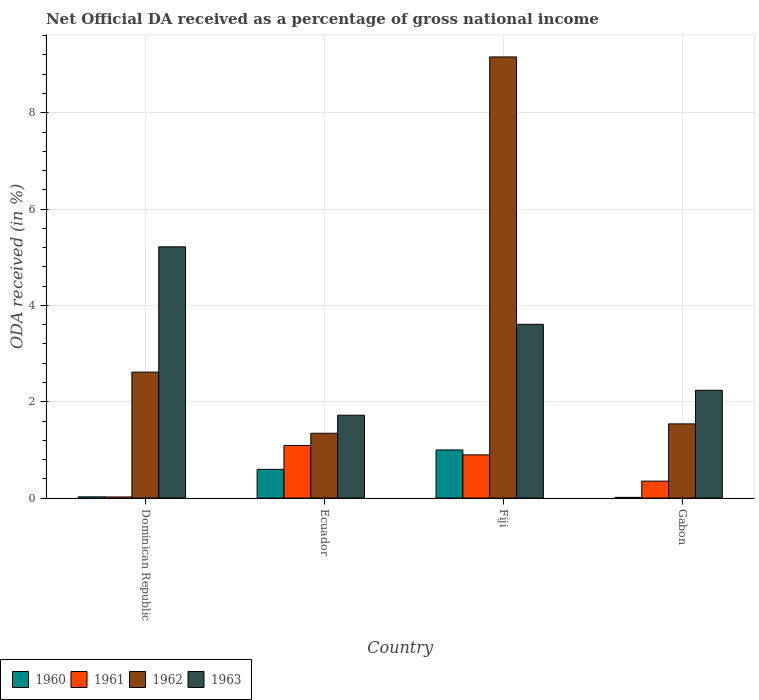How many groups of bars are there?
Provide a short and direct response. 4. Are the number of bars per tick equal to the number of legend labels?
Keep it short and to the point. Yes. How many bars are there on the 3rd tick from the right?
Provide a succinct answer. 4. What is the label of the 1st group of bars from the left?
Ensure brevity in your answer.  Dominican Republic. What is the net official DA received in 1962 in Dominican Republic?
Your response must be concise. 2.62. Across all countries, what is the maximum net official DA received in 1963?
Make the answer very short. 5.22. Across all countries, what is the minimum net official DA received in 1961?
Give a very brief answer. 0.02. In which country was the net official DA received in 1961 maximum?
Ensure brevity in your answer.  Ecuador. In which country was the net official DA received in 1960 minimum?
Offer a very short reply. Gabon. What is the total net official DA received in 1962 in the graph?
Provide a succinct answer. 14.66. What is the difference between the net official DA received in 1962 in Dominican Republic and that in Ecuador?
Ensure brevity in your answer.  1.27. What is the difference between the net official DA received in 1960 in Gabon and the net official DA received in 1961 in Ecuador?
Offer a terse response. -1.08. What is the average net official DA received in 1961 per country?
Offer a very short reply. 0.59. What is the difference between the net official DA received of/in 1961 and net official DA received of/in 1962 in Fiji?
Ensure brevity in your answer.  -8.26. In how many countries, is the net official DA received in 1963 greater than 1.6 %?
Your answer should be compact. 4. What is the ratio of the net official DA received in 1962 in Fiji to that in Gabon?
Provide a short and direct response. 5.94. Is the net official DA received in 1962 in Fiji less than that in Gabon?
Offer a terse response. No. What is the difference between the highest and the second highest net official DA received in 1963?
Provide a succinct answer. -1.37. What is the difference between the highest and the lowest net official DA received in 1960?
Provide a short and direct response. 0.98. In how many countries, is the net official DA received in 1962 greater than the average net official DA received in 1962 taken over all countries?
Provide a succinct answer. 1. What does the 4th bar from the left in Dominican Republic represents?
Make the answer very short. 1963. Is it the case that in every country, the sum of the net official DA received in 1962 and net official DA received in 1960 is greater than the net official DA received in 1963?
Offer a terse response. No. How many bars are there?
Give a very brief answer. 16. Are all the bars in the graph horizontal?
Provide a short and direct response. No. How many countries are there in the graph?
Your response must be concise. 4. Does the graph contain any zero values?
Your answer should be very brief. No. Does the graph contain grids?
Give a very brief answer. Yes. Where does the legend appear in the graph?
Provide a short and direct response. Bottom left. How are the legend labels stacked?
Keep it short and to the point. Horizontal. What is the title of the graph?
Keep it short and to the point. Net Official DA received as a percentage of gross national income. What is the label or title of the X-axis?
Your response must be concise. Country. What is the label or title of the Y-axis?
Offer a very short reply. ODA received (in %). What is the ODA received (in %) in 1960 in Dominican Republic?
Offer a terse response. 0.03. What is the ODA received (in %) of 1961 in Dominican Republic?
Make the answer very short. 0.02. What is the ODA received (in %) in 1962 in Dominican Republic?
Offer a very short reply. 2.62. What is the ODA received (in %) of 1963 in Dominican Republic?
Give a very brief answer. 5.22. What is the ODA received (in %) in 1960 in Ecuador?
Your answer should be compact. 0.6. What is the ODA received (in %) in 1961 in Ecuador?
Give a very brief answer. 1.09. What is the ODA received (in %) of 1962 in Ecuador?
Ensure brevity in your answer.  1.35. What is the ODA received (in %) of 1963 in Ecuador?
Offer a very short reply. 1.72. What is the ODA received (in %) in 1960 in Fiji?
Provide a succinct answer. 1. What is the ODA received (in %) of 1961 in Fiji?
Keep it short and to the point. 0.9. What is the ODA received (in %) of 1962 in Fiji?
Offer a very short reply. 9.16. What is the ODA received (in %) of 1963 in Fiji?
Ensure brevity in your answer.  3.61. What is the ODA received (in %) in 1960 in Gabon?
Offer a very short reply. 0.01. What is the ODA received (in %) in 1961 in Gabon?
Provide a succinct answer. 0.35. What is the ODA received (in %) in 1962 in Gabon?
Make the answer very short. 1.54. What is the ODA received (in %) in 1963 in Gabon?
Keep it short and to the point. 2.24. Across all countries, what is the maximum ODA received (in %) of 1960?
Give a very brief answer. 1. Across all countries, what is the maximum ODA received (in %) in 1961?
Ensure brevity in your answer.  1.09. Across all countries, what is the maximum ODA received (in %) in 1962?
Your answer should be compact. 9.16. Across all countries, what is the maximum ODA received (in %) of 1963?
Your answer should be compact. 5.22. Across all countries, what is the minimum ODA received (in %) of 1960?
Your response must be concise. 0.01. Across all countries, what is the minimum ODA received (in %) of 1961?
Give a very brief answer. 0.02. Across all countries, what is the minimum ODA received (in %) of 1962?
Offer a terse response. 1.35. Across all countries, what is the minimum ODA received (in %) of 1963?
Your response must be concise. 1.72. What is the total ODA received (in %) in 1960 in the graph?
Give a very brief answer. 1.64. What is the total ODA received (in %) in 1961 in the graph?
Provide a succinct answer. 2.37. What is the total ODA received (in %) of 1962 in the graph?
Offer a very short reply. 14.66. What is the total ODA received (in %) of 1963 in the graph?
Offer a very short reply. 12.78. What is the difference between the ODA received (in %) in 1960 in Dominican Republic and that in Ecuador?
Provide a succinct answer. -0.57. What is the difference between the ODA received (in %) in 1961 in Dominican Republic and that in Ecuador?
Offer a terse response. -1.07. What is the difference between the ODA received (in %) in 1962 in Dominican Republic and that in Ecuador?
Provide a short and direct response. 1.27. What is the difference between the ODA received (in %) in 1963 in Dominican Republic and that in Ecuador?
Your answer should be very brief. 3.5. What is the difference between the ODA received (in %) in 1960 in Dominican Republic and that in Fiji?
Provide a succinct answer. -0.97. What is the difference between the ODA received (in %) of 1961 in Dominican Republic and that in Fiji?
Your response must be concise. -0.87. What is the difference between the ODA received (in %) of 1962 in Dominican Republic and that in Fiji?
Offer a terse response. -6.54. What is the difference between the ODA received (in %) of 1963 in Dominican Republic and that in Fiji?
Make the answer very short. 1.61. What is the difference between the ODA received (in %) of 1960 in Dominican Republic and that in Gabon?
Offer a very short reply. 0.01. What is the difference between the ODA received (in %) in 1961 in Dominican Republic and that in Gabon?
Offer a terse response. -0.33. What is the difference between the ODA received (in %) in 1962 in Dominican Republic and that in Gabon?
Offer a very short reply. 1.07. What is the difference between the ODA received (in %) of 1963 in Dominican Republic and that in Gabon?
Your answer should be compact. 2.98. What is the difference between the ODA received (in %) in 1960 in Ecuador and that in Fiji?
Make the answer very short. -0.4. What is the difference between the ODA received (in %) in 1961 in Ecuador and that in Fiji?
Your answer should be compact. 0.2. What is the difference between the ODA received (in %) in 1962 in Ecuador and that in Fiji?
Keep it short and to the point. -7.81. What is the difference between the ODA received (in %) of 1963 in Ecuador and that in Fiji?
Give a very brief answer. -1.89. What is the difference between the ODA received (in %) in 1960 in Ecuador and that in Gabon?
Provide a succinct answer. 0.58. What is the difference between the ODA received (in %) in 1961 in Ecuador and that in Gabon?
Ensure brevity in your answer.  0.74. What is the difference between the ODA received (in %) in 1962 in Ecuador and that in Gabon?
Your response must be concise. -0.2. What is the difference between the ODA received (in %) of 1963 in Ecuador and that in Gabon?
Ensure brevity in your answer.  -0.52. What is the difference between the ODA received (in %) of 1960 in Fiji and that in Gabon?
Make the answer very short. 0.98. What is the difference between the ODA received (in %) in 1961 in Fiji and that in Gabon?
Provide a short and direct response. 0.55. What is the difference between the ODA received (in %) of 1962 in Fiji and that in Gabon?
Give a very brief answer. 7.62. What is the difference between the ODA received (in %) in 1963 in Fiji and that in Gabon?
Make the answer very short. 1.37. What is the difference between the ODA received (in %) of 1960 in Dominican Republic and the ODA received (in %) of 1961 in Ecuador?
Provide a short and direct response. -1.07. What is the difference between the ODA received (in %) of 1960 in Dominican Republic and the ODA received (in %) of 1962 in Ecuador?
Provide a short and direct response. -1.32. What is the difference between the ODA received (in %) in 1960 in Dominican Republic and the ODA received (in %) in 1963 in Ecuador?
Offer a very short reply. -1.69. What is the difference between the ODA received (in %) of 1961 in Dominican Republic and the ODA received (in %) of 1962 in Ecuador?
Your response must be concise. -1.32. What is the difference between the ODA received (in %) in 1961 in Dominican Republic and the ODA received (in %) in 1963 in Ecuador?
Give a very brief answer. -1.7. What is the difference between the ODA received (in %) of 1962 in Dominican Republic and the ODA received (in %) of 1963 in Ecuador?
Keep it short and to the point. 0.9. What is the difference between the ODA received (in %) of 1960 in Dominican Republic and the ODA received (in %) of 1961 in Fiji?
Make the answer very short. -0.87. What is the difference between the ODA received (in %) in 1960 in Dominican Republic and the ODA received (in %) in 1962 in Fiji?
Provide a succinct answer. -9.13. What is the difference between the ODA received (in %) in 1960 in Dominican Republic and the ODA received (in %) in 1963 in Fiji?
Provide a short and direct response. -3.58. What is the difference between the ODA received (in %) in 1961 in Dominican Republic and the ODA received (in %) in 1962 in Fiji?
Provide a succinct answer. -9.14. What is the difference between the ODA received (in %) in 1961 in Dominican Republic and the ODA received (in %) in 1963 in Fiji?
Your response must be concise. -3.58. What is the difference between the ODA received (in %) in 1962 in Dominican Republic and the ODA received (in %) in 1963 in Fiji?
Your answer should be very brief. -0.99. What is the difference between the ODA received (in %) in 1960 in Dominican Republic and the ODA received (in %) in 1961 in Gabon?
Offer a very short reply. -0.33. What is the difference between the ODA received (in %) of 1960 in Dominican Republic and the ODA received (in %) of 1962 in Gabon?
Give a very brief answer. -1.52. What is the difference between the ODA received (in %) in 1960 in Dominican Republic and the ODA received (in %) in 1963 in Gabon?
Provide a succinct answer. -2.21. What is the difference between the ODA received (in %) in 1961 in Dominican Republic and the ODA received (in %) in 1962 in Gabon?
Give a very brief answer. -1.52. What is the difference between the ODA received (in %) of 1961 in Dominican Republic and the ODA received (in %) of 1963 in Gabon?
Your answer should be very brief. -2.21. What is the difference between the ODA received (in %) in 1962 in Dominican Republic and the ODA received (in %) in 1963 in Gabon?
Your answer should be very brief. 0.38. What is the difference between the ODA received (in %) of 1960 in Ecuador and the ODA received (in %) of 1961 in Fiji?
Make the answer very short. -0.3. What is the difference between the ODA received (in %) in 1960 in Ecuador and the ODA received (in %) in 1962 in Fiji?
Provide a short and direct response. -8.56. What is the difference between the ODA received (in %) in 1960 in Ecuador and the ODA received (in %) in 1963 in Fiji?
Ensure brevity in your answer.  -3.01. What is the difference between the ODA received (in %) in 1961 in Ecuador and the ODA received (in %) in 1962 in Fiji?
Offer a terse response. -8.07. What is the difference between the ODA received (in %) of 1961 in Ecuador and the ODA received (in %) of 1963 in Fiji?
Offer a very short reply. -2.52. What is the difference between the ODA received (in %) in 1962 in Ecuador and the ODA received (in %) in 1963 in Fiji?
Give a very brief answer. -2.26. What is the difference between the ODA received (in %) in 1960 in Ecuador and the ODA received (in %) in 1961 in Gabon?
Your answer should be very brief. 0.24. What is the difference between the ODA received (in %) of 1960 in Ecuador and the ODA received (in %) of 1962 in Gabon?
Your answer should be very brief. -0.94. What is the difference between the ODA received (in %) of 1960 in Ecuador and the ODA received (in %) of 1963 in Gabon?
Provide a succinct answer. -1.64. What is the difference between the ODA received (in %) of 1961 in Ecuador and the ODA received (in %) of 1962 in Gabon?
Keep it short and to the point. -0.45. What is the difference between the ODA received (in %) of 1961 in Ecuador and the ODA received (in %) of 1963 in Gabon?
Provide a succinct answer. -1.15. What is the difference between the ODA received (in %) in 1962 in Ecuador and the ODA received (in %) in 1963 in Gabon?
Provide a short and direct response. -0.89. What is the difference between the ODA received (in %) in 1960 in Fiji and the ODA received (in %) in 1961 in Gabon?
Give a very brief answer. 0.65. What is the difference between the ODA received (in %) in 1960 in Fiji and the ODA received (in %) in 1962 in Gabon?
Provide a succinct answer. -0.54. What is the difference between the ODA received (in %) of 1960 in Fiji and the ODA received (in %) of 1963 in Gabon?
Ensure brevity in your answer.  -1.24. What is the difference between the ODA received (in %) of 1961 in Fiji and the ODA received (in %) of 1962 in Gabon?
Your answer should be compact. -0.64. What is the difference between the ODA received (in %) of 1961 in Fiji and the ODA received (in %) of 1963 in Gabon?
Provide a short and direct response. -1.34. What is the difference between the ODA received (in %) in 1962 in Fiji and the ODA received (in %) in 1963 in Gabon?
Provide a succinct answer. 6.92. What is the average ODA received (in %) of 1960 per country?
Give a very brief answer. 0.41. What is the average ODA received (in %) of 1961 per country?
Your answer should be compact. 0.59. What is the average ODA received (in %) of 1962 per country?
Ensure brevity in your answer.  3.67. What is the average ODA received (in %) in 1963 per country?
Provide a succinct answer. 3.2. What is the difference between the ODA received (in %) of 1960 and ODA received (in %) of 1961 in Dominican Republic?
Provide a succinct answer. 0. What is the difference between the ODA received (in %) in 1960 and ODA received (in %) in 1962 in Dominican Republic?
Provide a short and direct response. -2.59. What is the difference between the ODA received (in %) of 1960 and ODA received (in %) of 1963 in Dominican Republic?
Provide a succinct answer. -5.19. What is the difference between the ODA received (in %) of 1961 and ODA received (in %) of 1962 in Dominican Republic?
Your response must be concise. -2.59. What is the difference between the ODA received (in %) of 1961 and ODA received (in %) of 1963 in Dominican Republic?
Your answer should be very brief. -5.19. What is the difference between the ODA received (in %) of 1962 and ODA received (in %) of 1963 in Dominican Republic?
Your answer should be compact. -2.6. What is the difference between the ODA received (in %) of 1960 and ODA received (in %) of 1961 in Ecuador?
Your answer should be compact. -0.5. What is the difference between the ODA received (in %) in 1960 and ODA received (in %) in 1962 in Ecuador?
Your response must be concise. -0.75. What is the difference between the ODA received (in %) in 1960 and ODA received (in %) in 1963 in Ecuador?
Provide a short and direct response. -1.12. What is the difference between the ODA received (in %) of 1961 and ODA received (in %) of 1962 in Ecuador?
Make the answer very short. -0.25. What is the difference between the ODA received (in %) of 1961 and ODA received (in %) of 1963 in Ecuador?
Offer a terse response. -0.63. What is the difference between the ODA received (in %) in 1962 and ODA received (in %) in 1963 in Ecuador?
Your answer should be very brief. -0.37. What is the difference between the ODA received (in %) of 1960 and ODA received (in %) of 1961 in Fiji?
Provide a short and direct response. 0.1. What is the difference between the ODA received (in %) of 1960 and ODA received (in %) of 1962 in Fiji?
Keep it short and to the point. -8.16. What is the difference between the ODA received (in %) in 1960 and ODA received (in %) in 1963 in Fiji?
Your answer should be very brief. -2.61. What is the difference between the ODA received (in %) of 1961 and ODA received (in %) of 1962 in Fiji?
Ensure brevity in your answer.  -8.26. What is the difference between the ODA received (in %) in 1961 and ODA received (in %) in 1963 in Fiji?
Make the answer very short. -2.71. What is the difference between the ODA received (in %) in 1962 and ODA received (in %) in 1963 in Fiji?
Your answer should be compact. 5.55. What is the difference between the ODA received (in %) of 1960 and ODA received (in %) of 1961 in Gabon?
Offer a very short reply. -0.34. What is the difference between the ODA received (in %) of 1960 and ODA received (in %) of 1962 in Gabon?
Your answer should be very brief. -1.53. What is the difference between the ODA received (in %) in 1960 and ODA received (in %) in 1963 in Gabon?
Provide a short and direct response. -2.22. What is the difference between the ODA received (in %) of 1961 and ODA received (in %) of 1962 in Gabon?
Your response must be concise. -1.19. What is the difference between the ODA received (in %) of 1961 and ODA received (in %) of 1963 in Gabon?
Ensure brevity in your answer.  -1.89. What is the difference between the ODA received (in %) of 1962 and ODA received (in %) of 1963 in Gabon?
Offer a terse response. -0.7. What is the ratio of the ODA received (in %) of 1960 in Dominican Republic to that in Ecuador?
Ensure brevity in your answer.  0.04. What is the ratio of the ODA received (in %) of 1961 in Dominican Republic to that in Ecuador?
Ensure brevity in your answer.  0.02. What is the ratio of the ODA received (in %) of 1962 in Dominican Republic to that in Ecuador?
Provide a short and direct response. 1.94. What is the ratio of the ODA received (in %) of 1963 in Dominican Republic to that in Ecuador?
Make the answer very short. 3.03. What is the ratio of the ODA received (in %) in 1960 in Dominican Republic to that in Fiji?
Give a very brief answer. 0.03. What is the ratio of the ODA received (in %) in 1961 in Dominican Republic to that in Fiji?
Your answer should be very brief. 0.03. What is the ratio of the ODA received (in %) in 1962 in Dominican Republic to that in Fiji?
Make the answer very short. 0.29. What is the ratio of the ODA received (in %) in 1963 in Dominican Republic to that in Fiji?
Provide a succinct answer. 1.45. What is the ratio of the ODA received (in %) in 1960 in Dominican Republic to that in Gabon?
Offer a terse response. 1.73. What is the ratio of the ODA received (in %) of 1961 in Dominican Republic to that in Gabon?
Make the answer very short. 0.07. What is the ratio of the ODA received (in %) in 1962 in Dominican Republic to that in Gabon?
Give a very brief answer. 1.7. What is the ratio of the ODA received (in %) in 1963 in Dominican Republic to that in Gabon?
Your response must be concise. 2.33. What is the ratio of the ODA received (in %) in 1960 in Ecuador to that in Fiji?
Keep it short and to the point. 0.6. What is the ratio of the ODA received (in %) of 1961 in Ecuador to that in Fiji?
Offer a terse response. 1.22. What is the ratio of the ODA received (in %) in 1962 in Ecuador to that in Fiji?
Offer a terse response. 0.15. What is the ratio of the ODA received (in %) in 1963 in Ecuador to that in Fiji?
Provide a short and direct response. 0.48. What is the ratio of the ODA received (in %) of 1960 in Ecuador to that in Gabon?
Offer a very short reply. 40.19. What is the ratio of the ODA received (in %) in 1961 in Ecuador to that in Gabon?
Offer a terse response. 3.1. What is the ratio of the ODA received (in %) in 1962 in Ecuador to that in Gabon?
Your answer should be compact. 0.87. What is the ratio of the ODA received (in %) in 1963 in Ecuador to that in Gabon?
Provide a short and direct response. 0.77. What is the ratio of the ODA received (in %) in 1960 in Fiji to that in Gabon?
Offer a terse response. 67.36. What is the ratio of the ODA received (in %) in 1961 in Fiji to that in Gabon?
Your answer should be compact. 2.55. What is the ratio of the ODA received (in %) of 1962 in Fiji to that in Gabon?
Your answer should be very brief. 5.94. What is the ratio of the ODA received (in %) of 1963 in Fiji to that in Gabon?
Your answer should be compact. 1.61. What is the difference between the highest and the second highest ODA received (in %) of 1960?
Provide a succinct answer. 0.4. What is the difference between the highest and the second highest ODA received (in %) of 1961?
Keep it short and to the point. 0.2. What is the difference between the highest and the second highest ODA received (in %) of 1962?
Your answer should be very brief. 6.54. What is the difference between the highest and the second highest ODA received (in %) of 1963?
Your answer should be compact. 1.61. What is the difference between the highest and the lowest ODA received (in %) in 1960?
Your answer should be very brief. 0.98. What is the difference between the highest and the lowest ODA received (in %) in 1961?
Make the answer very short. 1.07. What is the difference between the highest and the lowest ODA received (in %) in 1962?
Keep it short and to the point. 7.81. What is the difference between the highest and the lowest ODA received (in %) in 1963?
Provide a succinct answer. 3.5. 